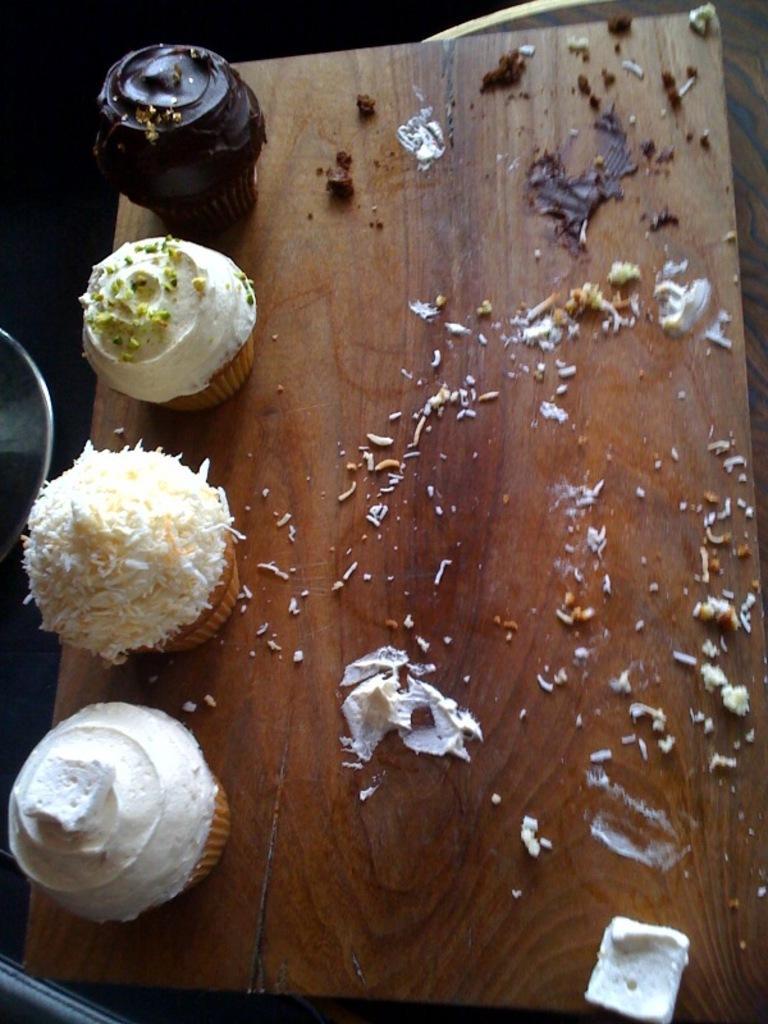Can you describe this image briefly? In this picture we can see few muffins on the wooden plank. 